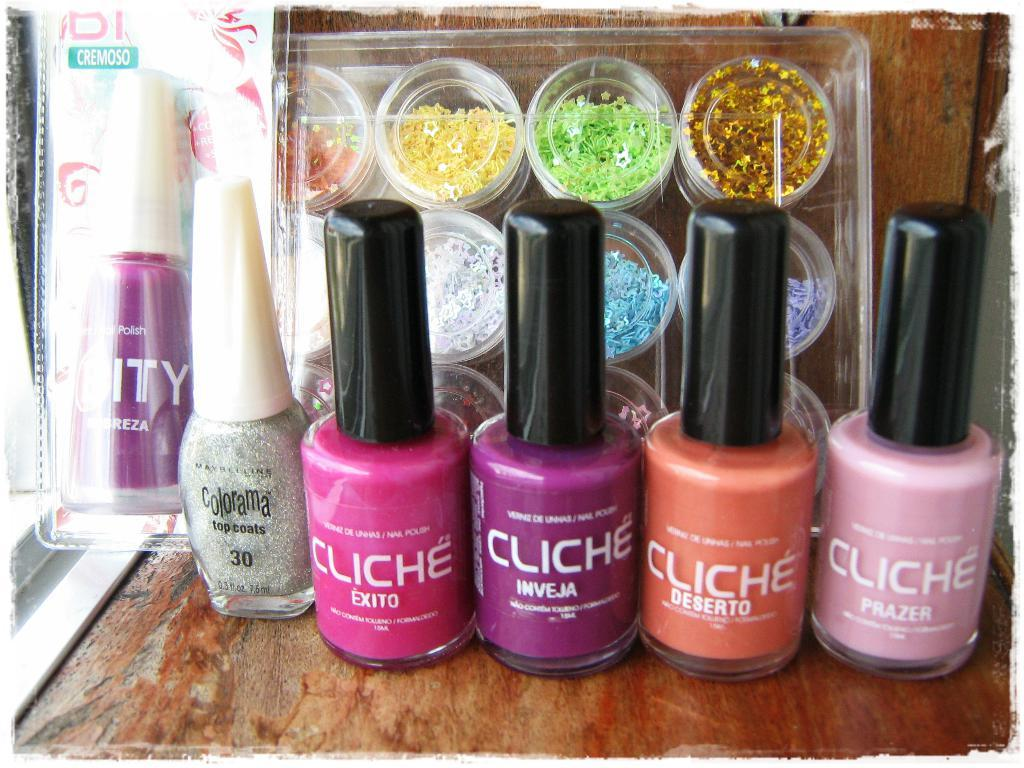What type of items are in the bottles visible in the image? There are bottles of nail paints in the image. What can be seen on the nail paint bottles? There is writing on the nail paint bottles. What type of containers are present in the image? There are plastic boxes in the image. What is inside the plastic boxes? The plastic boxes contain colorful things. What type of cheese is being stored in the plastic boxes in the image? There is no cheese present in the image; the plastic boxes contain colorful things, which are likely nail polish or other beauty products. 